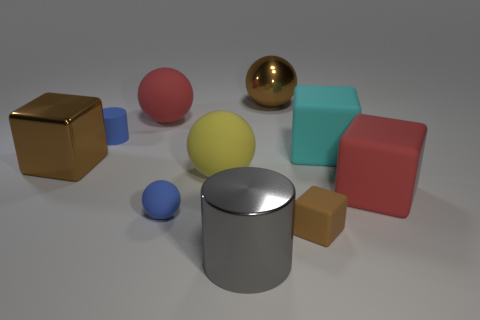What size is the cyan object that is made of the same material as the red cube?
Make the answer very short. Large. What number of big red matte cubes are behind the brown metal object that is to the right of the gray shiny cylinder?
Give a very brief answer. 0. There is a big brown cube; how many cyan blocks are in front of it?
Your response must be concise. 0. There is a ball to the right of the large metallic thing in front of the large block that is on the left side of the blue matte ball; what is its color?
Keep it short and to the point. Brown. Do the cylinder on the left side of the big cylinder and the cube on the left side of the brown matte block have the same color?
Offer a very short reply. No. There is a shiny thing that is to the left of the red matte thing behind the tiny blue cylinder; what is its shape?
Keep it short and to the point. Cube. Is there another gray object of the same size as the gray metal thing?
Your response must be concise. No. What number of rubber objects have the same shape as the big gray metal thing?
Make the answer very short. 1. Are there an equal number of brown matte things on the left side of the big brown shiny sphere and large cyan rubber things left of the big red block?
Ensure brevity in your answer.  No. Are any matte objects visible?
Keep it short and to the point. Yes. 